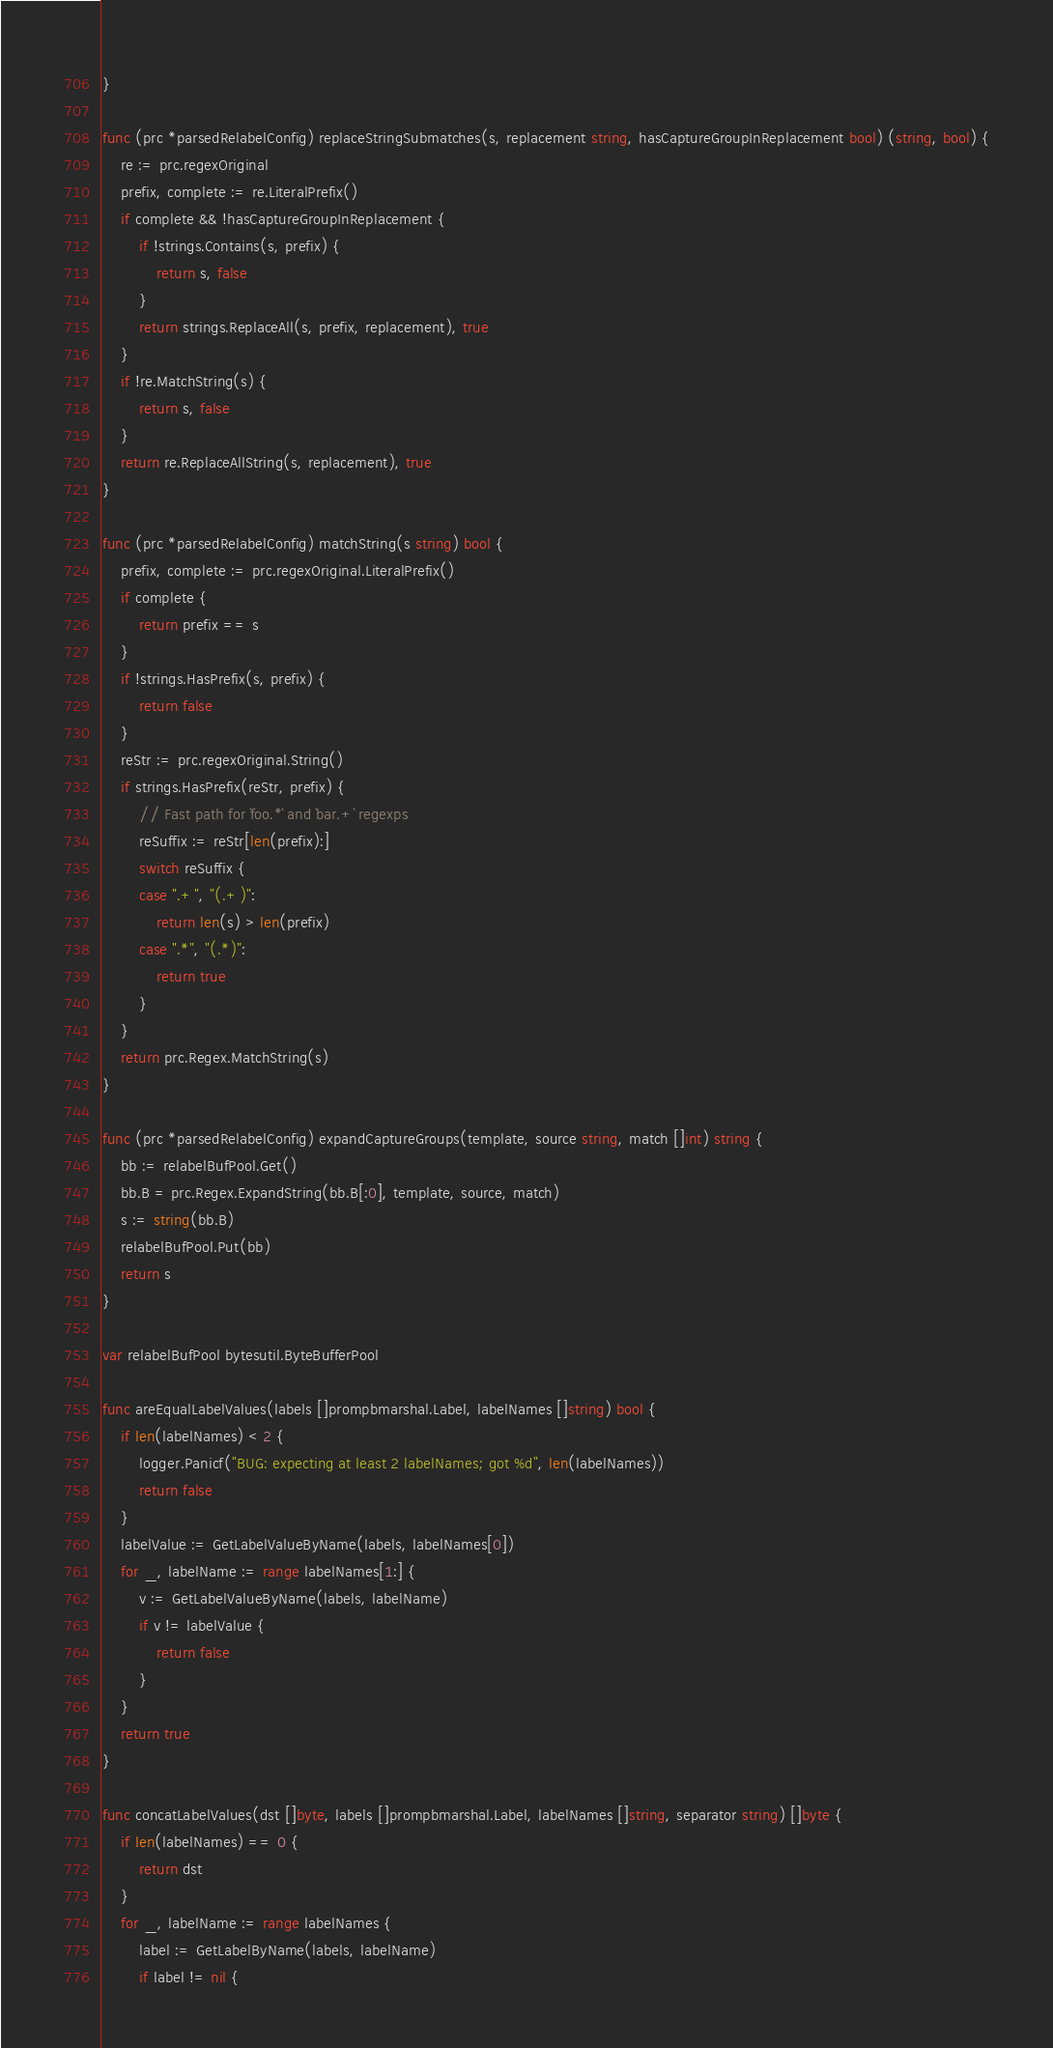<code> <loc_0><loc_0><loc_500><loc_500><_Go_>}

func (prc *parsedRelabelConfig) replaceStringSubmatches(s, replacement string, hasCaptureGroupInReplacement bool) (string, bool) {
	re := prc.regexOriginal
	prefix, complete := re.LiteralPrefix()
	if complete && !hasCaptureGroupInReplacement {
		if !strings.Contains(s, prefix) {
			return s, false
		}
		return strings.ReplaceAll(s, prefix, replacement), true
	}
	if !re.MatchString(s) {
		return s, false
	}
	return re.ReplaceAllString(s, replacement), true
}

func (prc *parsedRelabelConfig) matchString(s string) bool {
	prefix, complete := prc.regexOriginal.LiteralPrefix()
	if complete {
		return prefix == s
	}
	if !strings.HasPrefix(s, prefix) {
		return false
	}
	reStr := prc.regexOriginal.String()
	if strings.HasPrefix(reStr, prefix) {
		// Fast path for `foo.*` and `bar.+` regexps
		reSuffix := reStr[len(prefix):]
		switch reSuffix {
		case ".+", "(.+)":
			return len(s) > len(prefix)
		case ".*", "(.*)":
			return true
		}
	}
	return prc.Regex.MatchString(s)
}

func (prc *parsedRelabelConfig) expandCaptureGroups(template, source string, match []int) string {
	bb := relabelBufPool.Get()
	bb.B = prc.Regex.ExpandString(bb.B[:0], template, source, match)
	s := string(bb.B)
	relabelBufPool.Put(bb)
	return s
}

var relabelBufPool bytesutil.ByteBufferPool

func areEqualLabelValues(labels []prompbmarshal.Label, labelNames []string) bool {
	if len(labelNames) < 2 {
		logger.Panicf("BUG: expecting at least 2 labelNames; got %d", len(labelNames))
		return false
	}
	labelValue := GetLabelValueByName(labels, labelNames[0])
	for _, labelName := range labelNames[1:] {
		v := GetLabelValueByName(labels, labelName)
		if v != labelValue {
			return false
		}
	}
	return true
}

func concatLabelValues(dst []byte, labels []prompbmarshal.Label, labelNames []string, separator string) []byte {
	if len(labelNames) == 0 {
		return dst
	}
	for _, labelName := range labelNames {
		label := GetLabelByName(labels, labelName)
		if label != nil {</code> 